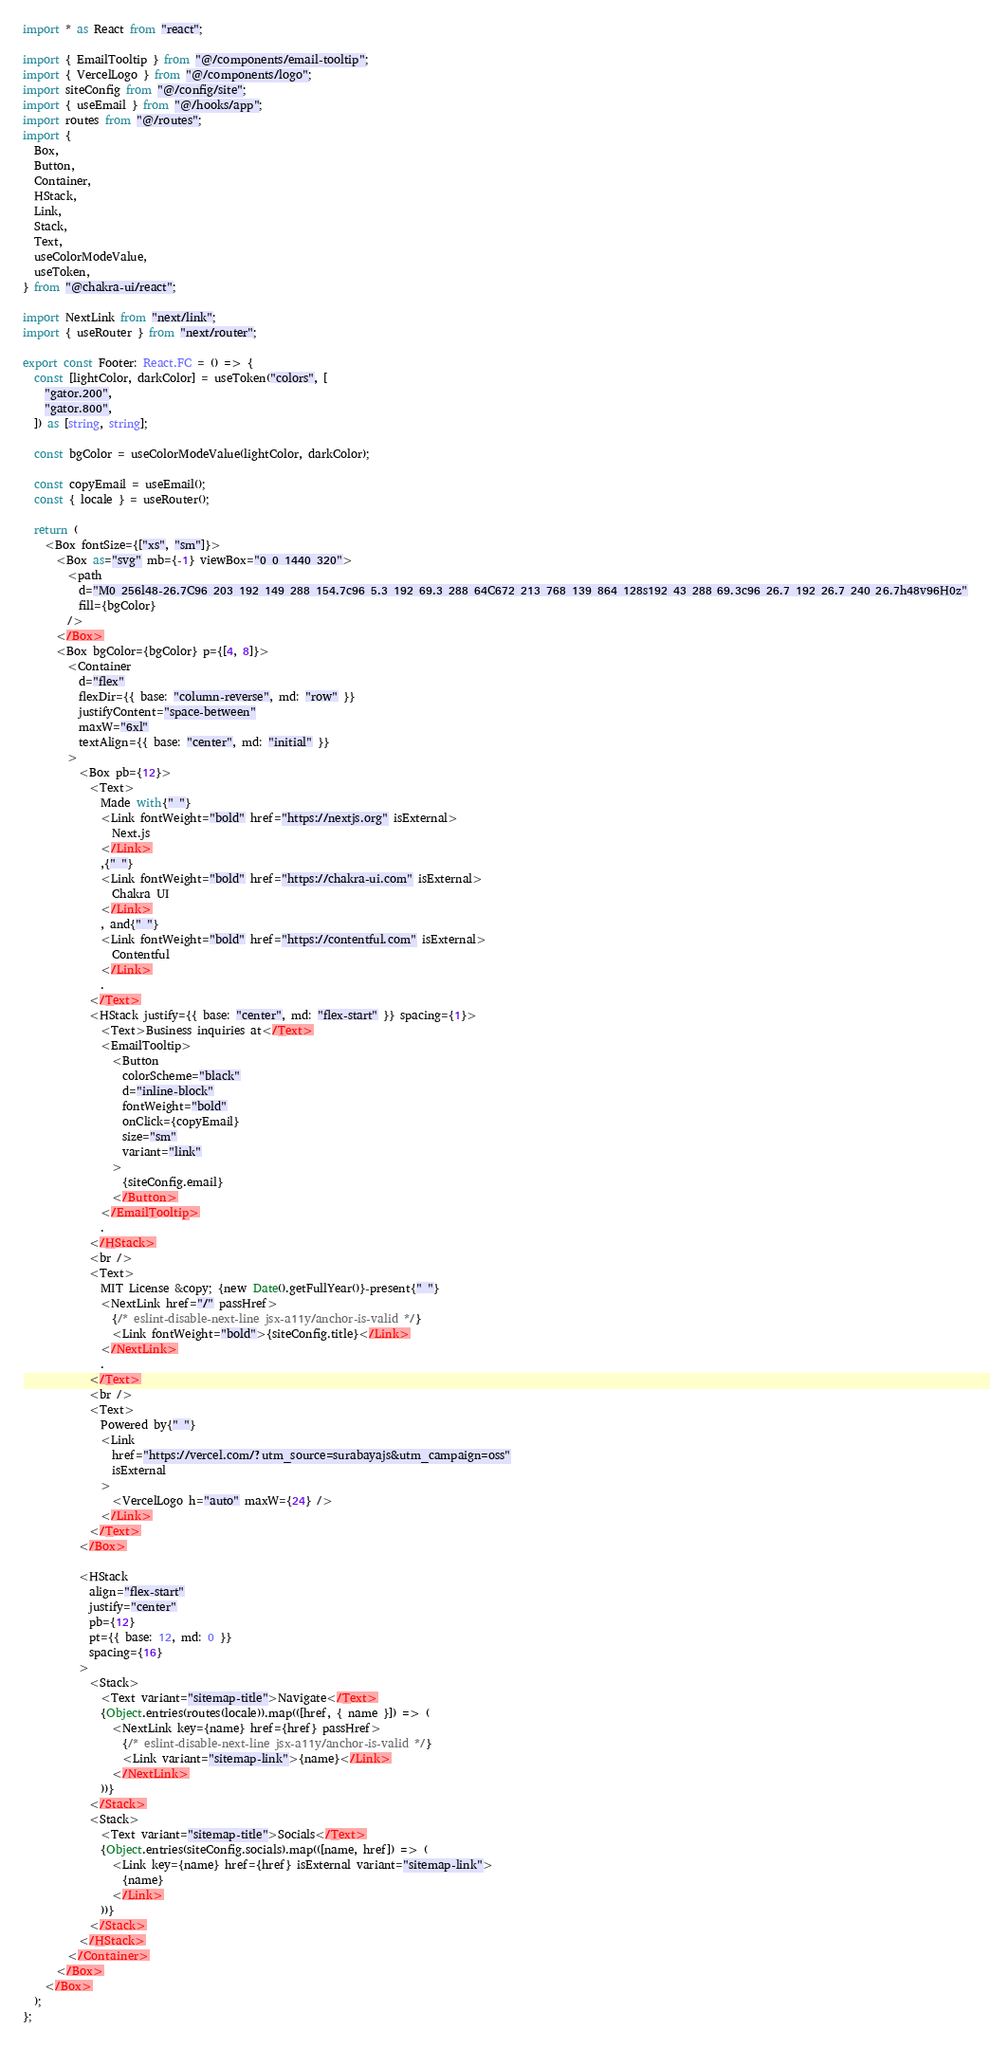Convert code to text. <code><loc_0><loc_0><loc_500><loc_500><_TypeScript_>import * as React from "react";

import { EmailTooltip } from "@/components/email-tooltip";
import { VercelLogo } from "@/components/logo";
import siteConfig from "@/config/site";
import { useEmail } from "@/hooks/app";
import routes from "@/routes";
import {
  Box,
  Button,
  Container,
  HStack,
  Link,
  Stack,
  Text,
  useColorModeValue,
  useToken,
} from "@chakra-ui/react";

import NextLink from "next/link";
import { useRouter } from "next/router";

export const Footer: React.FC = () => {
  const [lightColor, darkColor] = useToken("colors", [
    "gator.200",
    "gator.800",
  ]) as [string, string];

  const bgColor = useColorModeValue(lightColor, darkColor);

  const copyEmail = useEmail();
  const { locale } = useRouter();

  return (
    <Box fontSize={["xs", "sm"]}>
      <Box as="svg" mb={-1} viewBox="0 0 1440 320">
        <path
          d="M0 256l48-26.7C96 203 192 149 288 154.7c96 5.3 192 69.3 288 64C672 213 768 139 864 128s192 43 288 69.3c96 26.7 192 26.7 240 26.7h48v96H0z"
          fill={bgColor}
        />
      </Box>
      <Box bgColor={bgColor} p={[4, 8]}>
        <Container
          d="flex"
          flexDir={{ base: "column-reverse", md: "row" }}
          justifyContent="space-between"
          maxW="6xl"
          textAlign={{ base: "center", md: "initial" }}
        >
          <Box pb={12}>
            <Text>
              Made with{" "}
              <Link fontWeight="bold" href="https://nextjs.org" isExternal>
                Next.js
              </Link>
              ,{" "}
              <Link fontWeight="bold" href="https://chakra-ui.com" isExternal>
                Chakra UI
              </Link>
              , and{" "}
              <Link fontWeight="bold" href="https://contentful.com" isExternal>
                Contentful
              </Link>
              .
            </Text>
            <HStack justify={{ base: "center", md: "flex-start" }} spacing={1}>
              <Text>Business inquiries at</Text>
              <EmailTooltip>
                <Button
                  colorScheme="black"
                  d="inline-block"
                  fontWeight="bold"
                  onClick={copyEmail}
                  size="sm"
                  variant="link"
                >
                  {siteConfig.email}
                </Button>
              </EmailTooltip>
              .
            </HStack>
            <br />
            <Text>
              MIT License &copy; {new Date().getFullYear()}-present{" "}
              <NextLink href="/" passHref>
                {/* eslint-disable-next-line jsx-a11y/anchor-is-valid */}
                <Link fontWeight="bold">{siteConfig.title}</Link>
              </NextLink>
              .
            </Text>
            <br />
            <Text>
              Powered by{" "}
              <Link
                href="https://vercel.com/?utm_source=surabayajs&utm_campaign=oss"
                isExternal
              >
                <VercelLogo h="auto" maxW={24} />
              </Link>
            </Text>
          </Box>

          <HStack
            align="flex-start"
            justify="center"
            pb={12}
            pt={{ base: 12, md: 0 }}
            spacing={16}
          >
            <Stack>
              <Text variant="sitemap-title">Navigate</Text>
              {Object.entries(routes(locale)).map(([href, { name }]) => (
                <NextLink key={name} href={href} passHref>
                  {/* eslint-disable-next-line jsx-a11y/anchor-is-valid */}
                  <Link variant="sitemap-link">{name}</Link>
                </NextLink>
              ))}
            </Stack>
            <Stack>
              <Text variant="sitemap-title">Socials</Text>
              {Object.entries(siteConfig.socials).map(([name, href]) => (
                <Link key={name} href={href} isExternal variant="sitemap-link">
                  {name}
                </Link>
              ))}
            </Stack>
          </HStack>
        </Container>
      </Box>
    </Box>
  );
};
</code> 